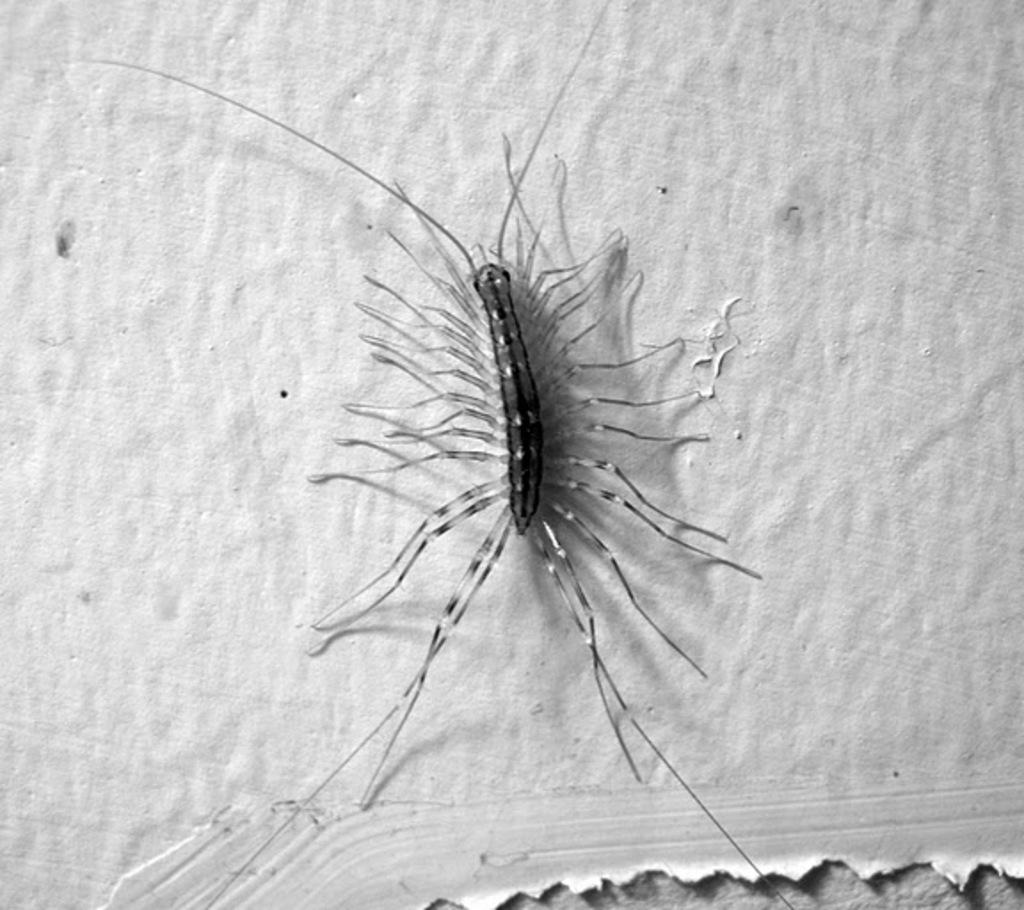What type of creature is present in the image? There is an insect in the image. Where is the insect located? The insect is on the wall. What type of deer can be seen on the floor in the image? There is no deer present in the image, and the floor is not visible in the provided facts. 